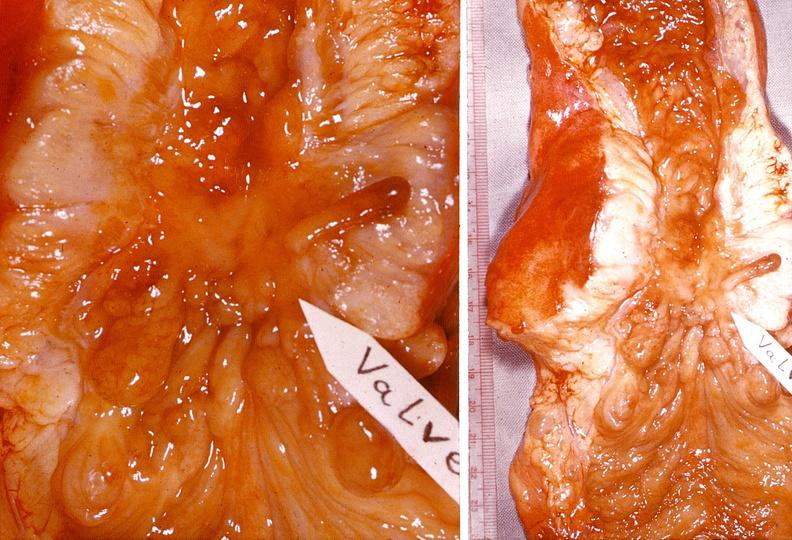where does this belong to?
Answer the question using a single word or phrase. Gastrointestinal system 